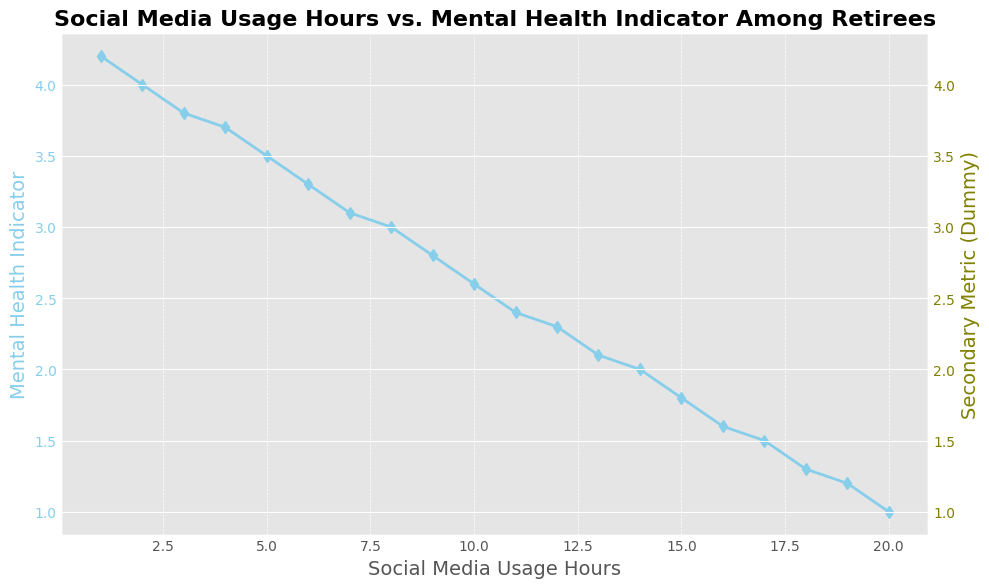What is the mental health indicator value at 6 hours of social media usage? Looking at the graph and locating the point at 6 hours of social media usage, the corresponding mental health indicator value is found to be 3.3.
Answer: 3.3 How much does the mental health indicator decrease between 2 and 4 hours of social media usage? The mental health indicator at 2 hours is 4.0 and at 4 hours is 3.7. The decrease is 4.0 - 3.7 = 0.3.
Answer: 0.3 What is the rate of change in the mental health indicator from 1 to 5 hours of social media usage? At 1 hour, the mental health indicator is 4.2, and at 5 hours, it is 3.5. The rate of change is (3.5 - 4.2) / (5 - 1) = -0.7 / 4 = -0.175 per hour.
Answer: -0.175 per hour At what point does the mental health indicator first go below 2.0? By observing the graph, the mental health indicator goes below 2.0 at 14 hours of social media usage.
Answer: 14 hours Compare the mental health indicator values at 10 and 15 hours of social media usage. Which is higher? At 10 hours, the mental health indicator is 2.6, and at 15 hours, it is 1.8. Therefore, the indicator is higher at 10 hours.
Answer: 10 hours How much does the mental health indicator decrease on average per hour of social media usage between 8 and 12 hours? At 8 hours, the indicator is 3.0, and at 12 hours, it is 2.3. The total decrease is 3.0 - 2.3 = 0.7 over 4 hours, so the average decrease is 0.7 / 4 = 0.175 per hour.
Answer: 0.175 per hour What is the minimum mental health indicator value visible in the graph? The minimum value of the mental health indicator visible in the graph is at 20 hours of social media usage, which is 1.0.
Answer: 1.0 If social media usage is doubled from 7 to 14 hours, by how much does the mental health indicator change? At 7 hours, the indicator is 3.1. At 14 hours, it is 2.0. The change is 3.1 - 2.0 = 1.1.
Answer: 1.1 At which hour is the mental health indicator closest to 3.0? By observing the graph, the mental health indicator is exactly 3.0 at 8 hours of social media usage.
Answer: 8 hours 